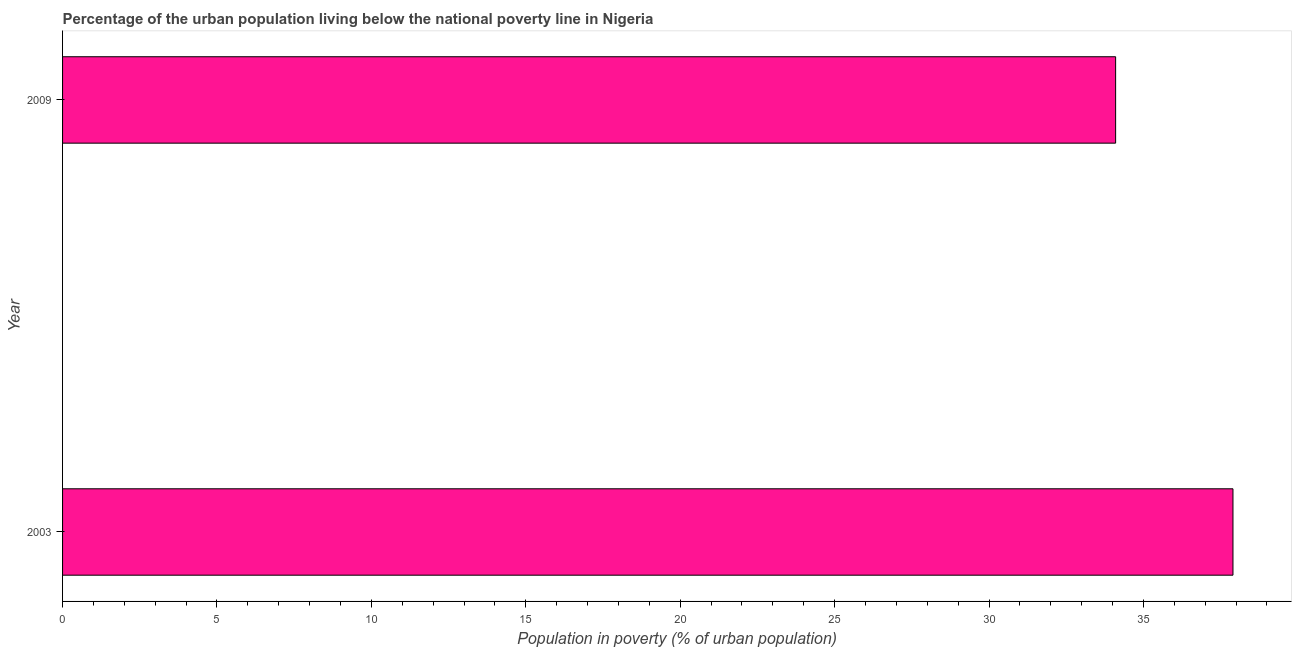Does the graph contain any zero values?
Provide a short and direct response. No. Does the graph contain grids?
Provide a succinct answer. No. What is the title of the graph?
Your answer should be very brief. Percentage of the urban population living below the national poverty line in Nigeria. What is the label or title of the X-axis?
Give a very brief answer. Population in poverty (% of urban population). What is the label or title of the Y-axis?
Offer a very short reply. Year. What is the percentage of urban population living below poverty line in 2009?
Offer a very short reply. 34.1. Across all years, what is the maximum percentage of urban population living below poverty line?
Give a very brief answer. 37.9. Across all years, what is the minimum percentage of urban population living below poverty line?
Ensure brevity in your answer.  34.1. In how many years, is the percentage of urban population living below poverty line greater than 4 %?
Your answer should be compact. 2. Do a majority of the years between 2003 and 2009 (inclusive) have percentage of urban population living below poverty line greater than 19 %?
Ensure brevity in your answer.  Yes. What is the ratio of the percentage of urban population living below poverty line in 2003 to that in 2009?
Make the answer very short. 1.11. How many bars are there?
Your answer should be compact. 2. How many years are there in the graph?
Your response must be concise. 2. What is the difference between two consecutive major ticks on the X-axis?
Offer a very short reply. 5. Are the values on the major ticks of X-axis written in scientific E-notation?
Keep it short and to the point. No. What is the Population in poverty (% of urban population) in 2003?
Provide a succinct answer. 37.9. What is the Population in poverty (% of urban population) of 2009?
Provide a succinct answer. 34.1. What is the difference between the Population in poverty (% of urban population) in 2003 and 2009?
Provide a short and direct response. 3.8. What is the ratio of the Population in poverty (% of urban population) in 2003 to that in 2009?
Provide a succinct answer. 1.11. 